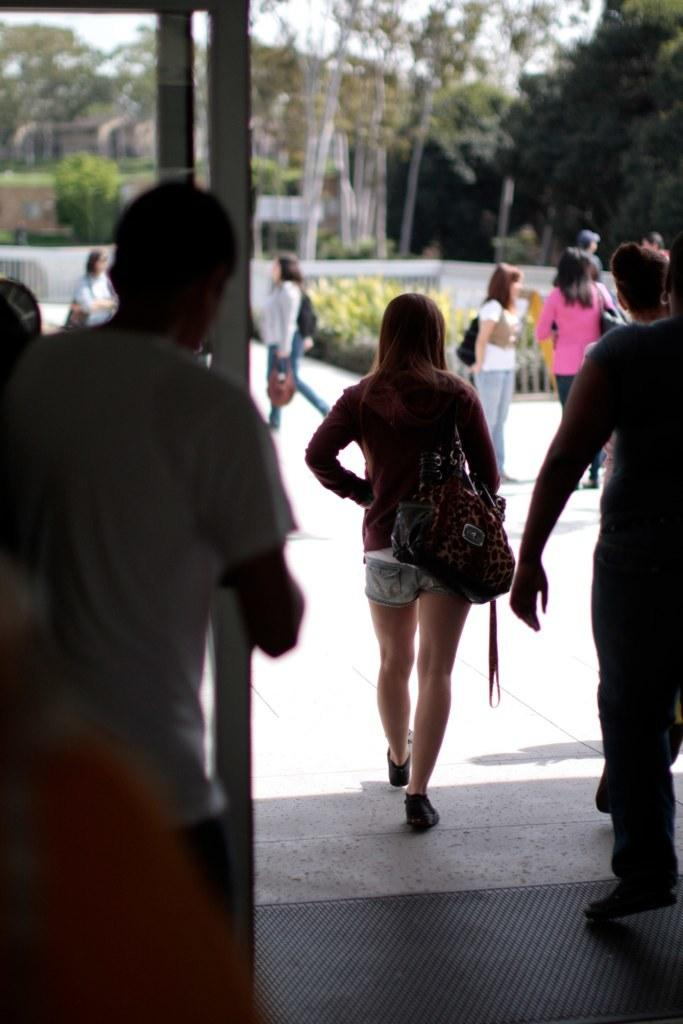Who can be seen in the image? There are people in the image. What is the woman carrying in the image? The woman is carrying a bag. What can be seen in the distance in the image? There are trees in the background of the image. What type of kitty can be seen playing with a mitten in the image? There is no kitty or mitten present in the image; it only features people and trees in the background. 